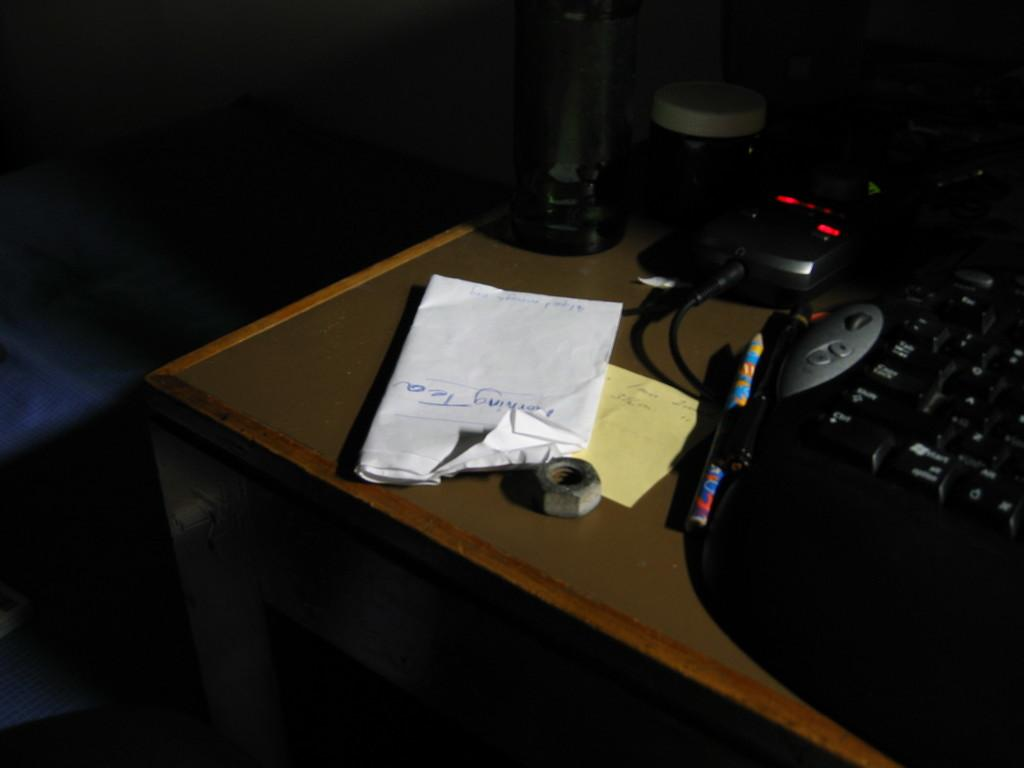<image>
Relay a brief, clear account of the picture shown. A paper on which "morning tea" is written is one of the items on the dark desk. 